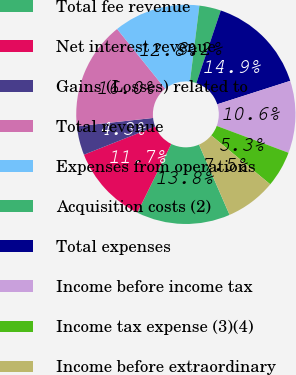Convert chart. <chart><loc_0><loc_0><loc_500><loc_500><pie_chart><fcel>Total fee revenue<fcel>Net interest revenue<fcel>Gains (Losses) related to<fcel>Total revenue<fcel>Expenses from operations<fcel>Acquisition costs (2)<fcel>Total expenses<fcel>Income before income tax<fcel>Income tax expense (3)(4)<fcel>Income before extraordinary<nl><fcel>13.83%<fcel>11.7%<fcel>4.26%<fcel>15.95%<fcel>12.76%<fcel>3.19%<fcel>14.89%<fcel>10.64%<fcel>5.32%<fcel>7.45%<nl></chart> 